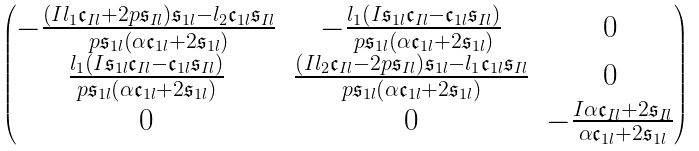Convert formula to latex. <formula><loc_0><loc_0><loc_500><loc_500>\begin{pmatrix} - \frac { \left ( I l _ { 1 } \mathfrak { c } _ { I l } + 2 p \mathfrak { s } _ { I l } \right ) \mathfrak { s } _ { 1 l } - l _ { 2 } \mathfrak { c } _ { 1 l } \mathfrak { s } _ { I l } } { p \mathfrak { s } _ { 1 l } \left ( \alpha \mathfrak { c } _ { 1 l } + 2 \mathfrak { s } _ { 1 l } \right ) } & - \frac { l _ { 1 } \left ( I \mathfrak { s } _ { 1 l } \mathfrak { c } _ { I l } - \mathfrak { c } _ { 1 l } \mathfrak { s } _ { I l } \right ) } { p \mathfrak { s } _ { 1 l } \left ( \alpha \mathfrak { c } _ { 1 l } + 2 \mathfrak { s } _ { 1 l } \right ) } & 0 \\ \frac { l _ { 1 } \left ( I \mathfrak { s } _ { 1 l } \mathfrak { c } _ { I l } - \mathfrak { c } _ { 1 l } \mathfrak { s } _ { I l } \right ) } { p \mathfrak { s } _ { 1 l } \left ( \alpha \mathfrak { c } _ { 1 l } + 2 \mathfrak { s } _ { 1 l } \right ) } & \frac { \left ( I l _ { 2 } \mathfrak { c } _ { I l } - 2 p \mathfrak { s } _ { I l } \right ) \mathfrak { s } _ { 1 l } - l _ { 1 } \mathfrak { c } _ { 1 l } \mathfrak { s } _ { I l } } { p \mathfrak { s } _ { 1 l } \left ( \alpha \mathfrak { c } _ { 1 l } + 2 \mathfrak { s } _ { 1 l } \right ) } & 0 \\ 0 & 0 & - \frac { I \alpha \mathfrak { c } _ { I l } + 2 \mathfrak { s } _ { I l } } { \alpha \mathfrak { c } _ { 1 l } + 2 \mathfrak { s } _ { 1 l } } \end{pmatrix}</formula> 